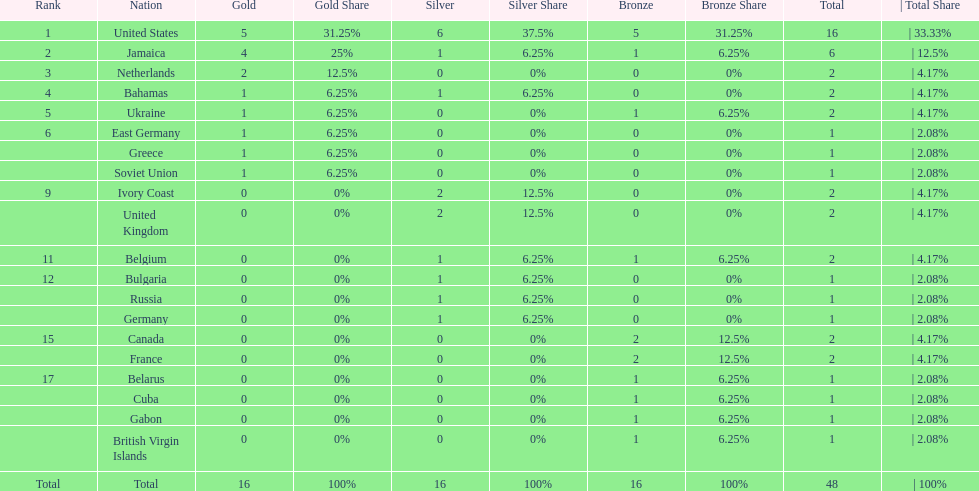How many gold medals did the us and jamaica win combined? 9. 